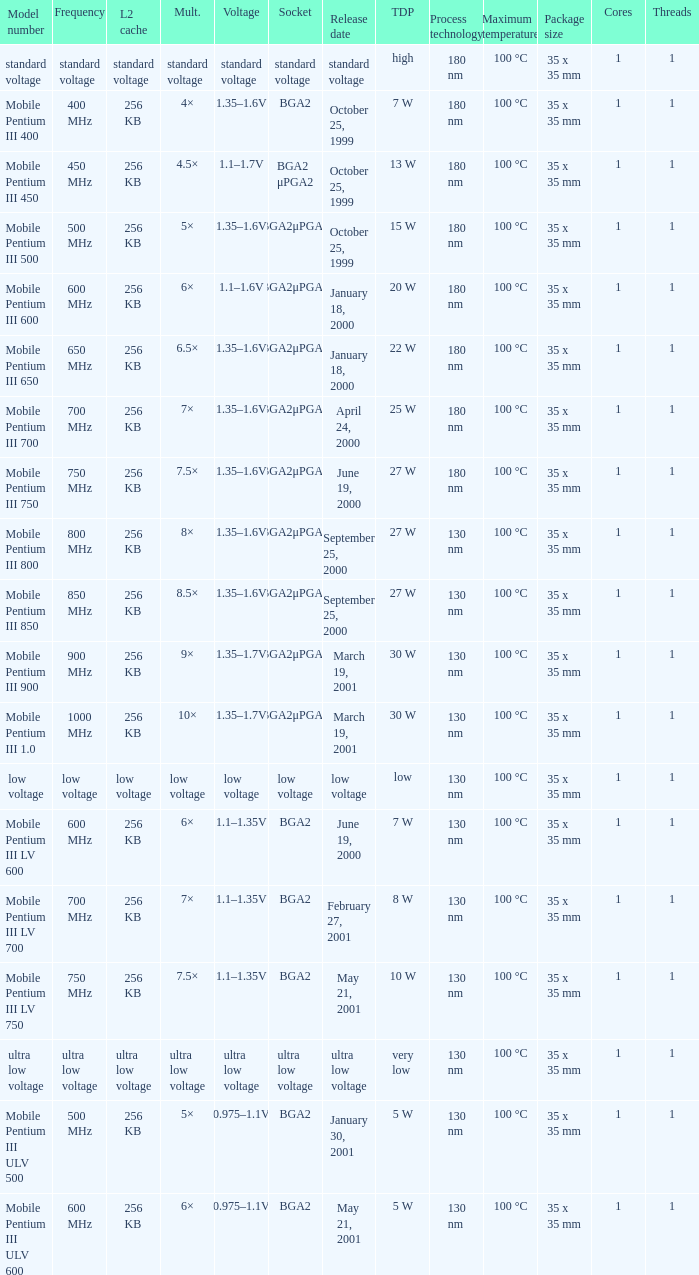Which model has a frequency of 750 mhz and a socket of bga2μpga2? Mobile Pentium III 750. 